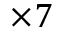<formula> <loc_0><loc_0><loc_500><loc_500>\times 7</formula> 